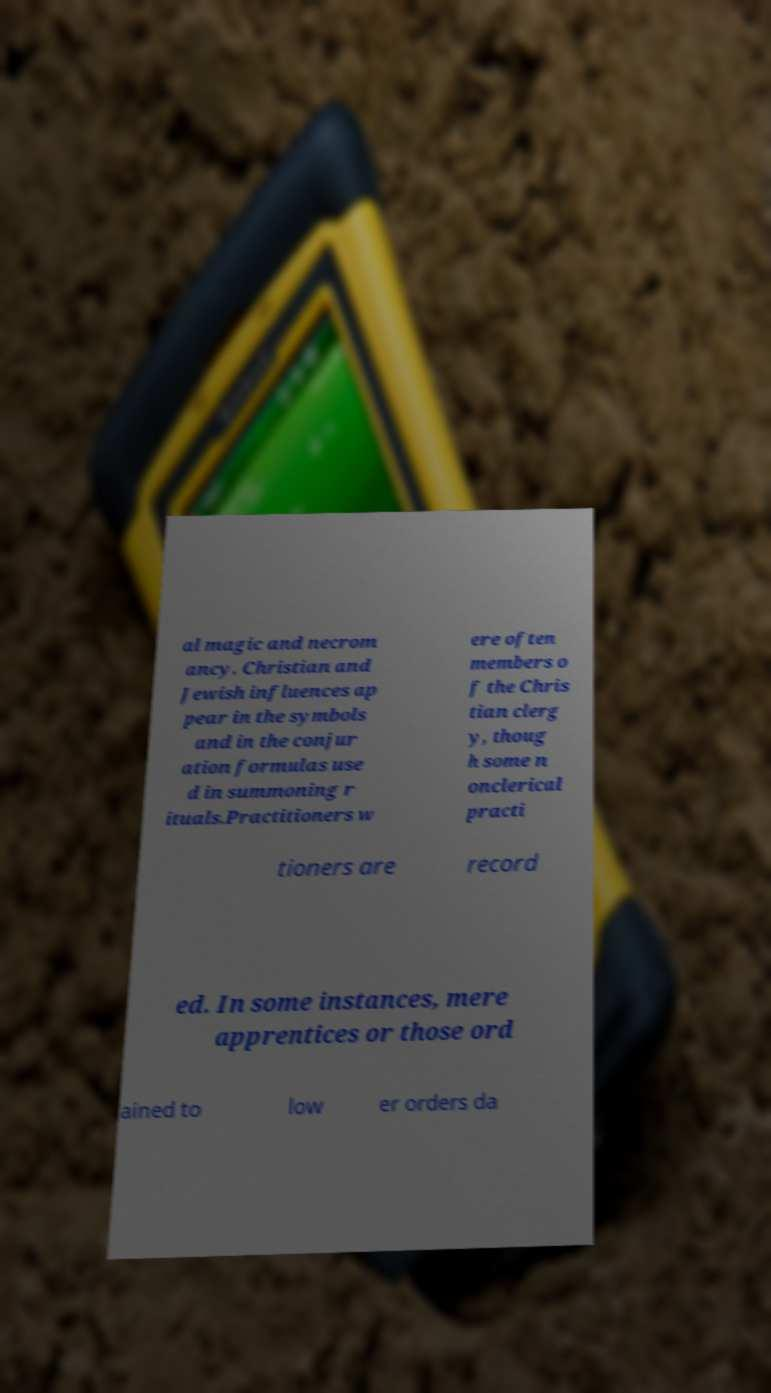What messages or text are displayed in this image? I need them in a readable, typed format. al magic and necrom ancy. Christian and Jewish influences ap pear in the symbols and in the conjur ation formulas use d in summoning r ituals.Practitioners w ere often members o f the Chris tian clerg y, thoug h some n onclerical practi tioners are record ed. In some instances, mere apprentices or those ord ained to low er orders da 